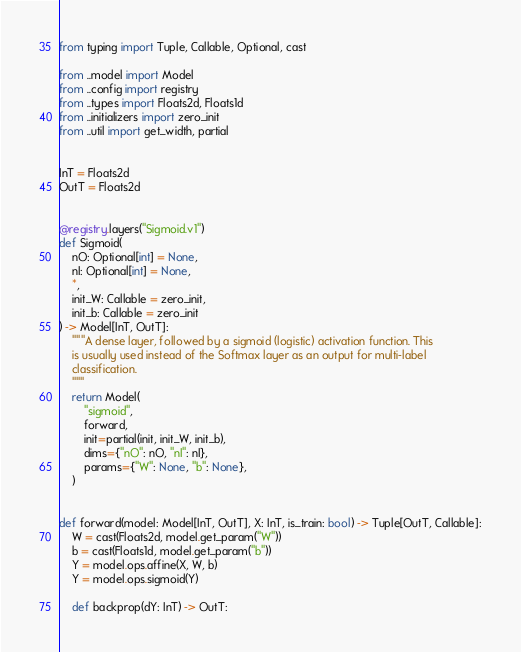Convert code to text. <code><loc_0><loc_0><loc_500><loc_500><_Python_>from typing import Tuple, Callable, Optional, cast

from ..model import Model
from ..config import registry
from ..types import Floats2d, Floats1d
from ..initializers import zero_init
from ..util import get_width, partial


InT = Floats2d
OutT = Floats2d


@registry.layers("Sigmoid.v1")
def Sigmoid(
    nO: Optional[int] = None,
    nI: Optional[int] = None,
    *,
    init_W: Callable = zero_init,
    init_b: Callable = zero_init
) -> Model[InT, OutT]:
    """A dense layer, followed by a sigmoid (logistic) activation function. This
    is usually used instead of the Softmax layer as an output for multi-label
    classification.
    """
    return Model(
        "sigmoid",
        forward,
        init=partial(init, init_W, init_b),
        dims={"nO": nO, "nI": nI},
        params={"W": None, "b": None},
    )


def forward(model: Model[InT, OutT], X: InT, is_train: bool) -> Tuple[OutT, Callable]:
    W = cast(Floats2d, model.get_param("W"))
    b = cast(Floats1d, model.get_param("b"))
    Y = model.ops.affine(X, W, b)
    Y = model.ops.sigmoid(Y)

    def backprop(dY: InT) -> OutT:</code> 